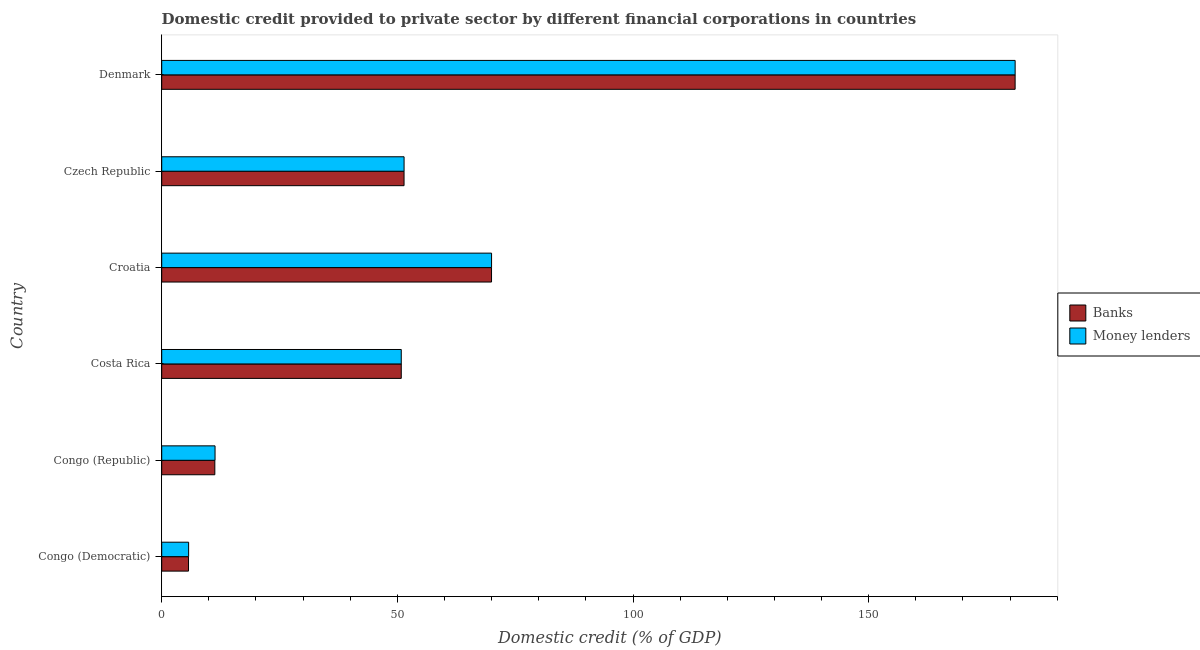How many different coloured bars are there?
Give a very brief answer. 2. How many groups of bars are there?
Make the answer very short. 6. Are the number of bars on each tick of the Y-axis equal?
Offer a very short reply. Yes. How many bars are there on the 1st tick from the top?
Offer a very short reply. 2. What is the label of the 6th group of bars from the top?
Give a very brief answer. Congo (Democratic). What is the domestic credit provided by banks in Denmark?
Your answer should be compact. 181.07. Across all countries, what is the maximum domestic credit provided by banks?
Keep it short and to the point. 181.07. Across all countries, what is the minimum domestic credit provided by money lenders?
Your answer should be compact. 5.71. In which country was the domestic credit provided by money lenders minimum?
Offer a terse response. Congo (Democratic). What is the total domestic credit provided by money lenders in the graph?
Your response must be concise. 370.34. What is the difference between the domestic credit provided by money lenders in Congo (Democratic) and that in Czech Republic?
Ensure brevity in your answer.  -45.71. What is the difference between the domestic credit provided by banks in Costa Rica and the domestic credit provided by money lenders in Congo (Democratic)?
Your response must be concise. 45.12. What is the average domestic credit provided by banks per country?
Provide a short and direct response. 61.71. What is the difference between the domestic credit provided by banks and domestic credit provided by money lenders in Denmark?
Keep it short and to the point. -0. Is the difference between the domestic credit provided by banks in Congo (Democratic) and Czech Republic greater than the difference between the domestic credit provided by money lenders in Congo (Democratic) and Czech Republic?
Your response must be concise. No. What is the difference between the highest and the second highest domestic credit provided by money lenders?
Keep it short and to the point. 111.09. What is the difference between the highest and the lowest domestic credit provided by money lenders?
Your response must be concise. 175.37. In how many countries, is the domestic credit provided by banks greater than the average domestic credit provided by banks taken over all countries?
Your answer should be compact. 2. What does the 1st bar from the top in Denmark represents?
Provide a succinct answer. Money lenders. What does the 1st bar from the bottom in Costa Rica represents?
Ensure brevity in your answer.  Banks. How many countries are there in the graph?
Offer a terse response. 6. What is the difference between two consecutive major ticks on the X-axis?
Ensure brevity in your answer.  50. Does the graph contain grids?
Offer a very short reply. No. How many legend labels are there?
Offer a terse response. 2. What is the title of the graph?
Make the answer very short. Domestic credit provided to private sector by different financial corporations in countries. Does "Revenue" appear as one of the legend labels in the graph?
Offer a very short reply. No. What is the label or title of the X-axis?
Provide a short and direct response. Domestic credit (% of GDP). What is the label or title of the Y-axis?
Provide a succinct answer. Country. What is the Domestic credit (% of GDP) in Banks in Congo (Democratic)?
Offer a terse response. 5.69. What is the Domestic credit (% of GDP) of Money lenders in Congo (Democratic)?
Provide a succinct answer. 5.71. What is the Domestic credit (% of GDP) in Banks in Congo (Republic)?
Make the answer very short. 11.27. What is the Domestic credit (% of GDP) of Money lenders in Congo (Republic)?
Provide a short and direct response. 11.32. What is the Domestic credit (% of GDP) of Banks in Costa Rica?
Offer a very short reply. 50.83. What is the Domestic credit (% of GDP) in Money lenders in Costa Rica?
Your response must be concise. 50.83. What is the Domestic credit (% of GDP) in Banks in Croatia?
Give a very brief answer. 69.98. What is the Domestic credit (% of GDP) of Money lenders in Croatia?
Ensure brevity in your answer.  69.99. What is the Domestic credit (% of GDP) in Banks in Czech Republic?
Your answer should be very brief. 51.42. What is the Domestic credit (% of GDP) in Money lenders in Czech Republic?
Keep it short and to the point. 51.42. What is the Domestic credit (% of GDP) of Banks in Denmark?
Offer a terse response. 181.07. What is the Domestic credit (% of GDP) of Money lenders in Denmark?
Make the answer very short. 181.08. Across all countries, what is the maximum Domestic credit (% of GDP) of Banks?
Your answer should be very brief. 181.07. Across all countries, what is the maximum Domestic credit (% of GDP) in Money lenders?
Keep it short and to the point. 181.08. Across all countries, what is the minimum Domestic credit (% of GDP) of Banks?
Your response must be concise. 5.69. Across all countries, what is the minimum Domestic credit (% of GDP) of Money lenders?
Provide a short and direct response. 5.71. What is the total Domestic credit (% of GDP) of Banks in the graph?
Offer a terse response. 370.26. What is the total Domestic credit (% of GDP) of Money lenders in the graph?
Offer a terse response. 370.34. What is the difference between the Domestic credit (% of GDP) in Banks in Congo (Democratic) and that in Congo (Republic)?
Ensure brevity in your answer.  -5.58. What is the difference between the Domestic credit (% of GDP) in Money lenders in Congo (Democratic) and that in Congo (Republic)?
Offer a very short reply. -5.61. What is the difference between the Domestic credit (% of GDP) in Banks in Congo (Democratic) and that in Costa Rica?
Your answer should be very brief. -45.14. What is the difference between the Domestic credit (% of GDP) of Money lenders in Congo (Democratic) and that in Costa Rica?
Your answer should be very brief. -45.12. What is the difference between the Domestic credit (% of GDP) of Banks in Congo (Democratic) and that in Croatia?
Ensure brevity in your answer.  -64.29. What is the difference between the Domestic credit (% of GDP) in Money lenders in Congo (Democratic) and that in Croatia?
Keep it short and to the point. -64.28. What is the difference between the Domestic credit (% of GDP) of Banks in Congo (Democratic) and that in Czech Republic?
Provide a succinct answer. -45.73. What is the difference between the Domestic credit (% of GDP) in Money lenders in Congo (Democratic) and that in Czech Republic?
Your response must be concise. -45.71. What is the difference between the Domestic credit (% of GDP) of Banks in Congo (Democratic) and that in Denmark?
Give a very brief answer. -175.39. What is the difference between the Domestic credit (% of GDP) in Money lenders in Congo (Democratic) and that in Denmark?
Keep it short and to the point. -175.37. What is the difference between the Domestic credit (% of GDP) in Banks in Congo (Republic) and that in Costa Rica?
Your response must be concise. -39.56. What is the difference between the Domestic credit (% of GDP) of Money lenders in Congo (Republic) and that in Costa Rica?
Offer a very short reply. -39.51. What is the difference between the Domestic credit (% of GDP) of Banks in Congo (Republic) and that in Croatia?
Offer a terse response. -58.71. What is the difference between the Domestic credit (% of GDP) in Money lenders in Congo (Republic) and that in Croatia?
Your answer should be very brief. -58.67. What is the difference between the Domestic credit (% of GDP) in Banks in Congo (Republic) and that in Czech Republic?
Your answer should be very brief. -40.15. What is the difference between the Domestic credit (% of GDP) in Money lenders in Congo (Republic) and that in Czech Republic?
Offer a terse response. -40.11. What is the difference between the Domestic credit (% of GDP) in Banks in Congo (Republic) and that in Denmark?
Make the answer very short. -169.8. What is the difference between the Domestic credit (% of GDP) of Money lenders in Congo (Republic) and that in Denmark?
Your answer should be compact. -169.76. What is the difference between the Domestic credit (% of GDP) of Banks in Costa Rica and that in Croatia?
Make the answer very short. -19.15. What is the difference between the Domestic credit (% of GDP) of Money lenders in Costa Rica and that in Croatia?
Provide a short and direct response. -19.16. What is the difference between the Domestic credit (% of GDP) in Banks in Costa Rica and that in Czech Republic?
Your answer should be compact. -0.59. What is the difference between the Domestic credit (% of GDP) of Money lenders in Costa Rica and that in Czech Republic?
Your answer should be very brief. -0.59. What is the difference between the Domestic credit (% of GDP) in Banks in Costa Rica and that in Denmark?
Keep it short and to the point. -130.25. What is the difference between the Domestic credit (% of GDP) in Money lenders in Costa Rica and that in Denmark?
Your answer should be very brief. -130.25. What is the difference between the Domestic credit (% of GDP) of Banks in Croatia and that in Czech Republic?
Your answer should be compact. 18.56. What is the difference between the Domestic credit (% of GDP) of Money lenders in Croatia and that in Czech Republic?
Your response must be concise. 18.56. What is the difference between the Domestic credit (% of GDP) of Banks in Croatia and that in Denmark?
Your answer should be very brief. -111.09. What is the difference between the Domestic credit (% of GDP) of Money lenders in Croatia and that in Denmark?
Your response must be concise. -111.09. What is the difference between the Domestic credit (% of GDP) of Banks in Czech Republic and that in Denmark?
Give a very brief answer. -129.66. What is the difference between the Domestic credit (% of GDP) in Money lenders in Czech Republic and that in Denmark?
Offer a terse response. -129.65. What is the difference between the Domestic credit (% of GDP) in Banks in Congo (Democratic) and the Domestic credit (% of GDP) in Money lenders in Congo (Republic)?
Offer a terse response. -5.63. What is the difference between the Domestic credit (% of GDP) of Banks in Congo (Democratic) and the Domestic credit (% of GDP) of Money lenders in Costa Rica?
Keep it short and to the point. -45.14. What is the difference between the Domestic credit (% of GDP) in Banks in Congo (Democratic) and the Domestic credit (% of GDP) in Money lenders in Croatia?
Provide a succinct answer. -64.3. What is the difference between the Domestic credit (% of GDP) in Banks in Congo (Democratic) and the Domestic credit (% of GDP) in Money lenders in Czech Republic?
Offer a very short reply. -45.74. What is the difference between the Domestic credit (% of GDP) in Banks in Congo (Democratic) and the Domestic credit (% of GDP) in Money lenders in Denmark?
Provide a succinct answer. -175.39. What is the difference between the Domestic credit (% of GDP) of Banks in Congo (Republic) and the Domestic credit (% of GDP) of Money lenders in Costa Rica?
Ensure brevity in your answer.  -39.56. What is the difference between the Domestic credit (% of GDP) of Banks in Congo (Republic) and the Domestic credit (% of GDP) of Money lenders in Croatia?
Ensure brevity in your answer.  -58.72. What is the difference between the Domestic credit (% of GDP) of Banks in Congo (Republic) and the Domestic credit (% of GDP) of Money lenders in Czech Republic?
Keep it short and to the point. -40.15. What is the difference between the Domestic credit (% of GDP) in Banks in Congo (Republic) and the Domestic credit (% of GDP) in Money lenders in Denmark?
Your response must be concise. -169.81. What is the difference between the Domestic credit (% of GDP) in Banks in Costa Rica and the Domestic credit (% of GDP) in Money lenders in Croatia?
Provide a succinct answer. -19.16. What is the difference between the Domestic credit (% of GDP) of Banks in Costa Rica and the Domestic credit (% of GDP) of Money lenders in Czech Republic?
Offer a very short reply. -0.59. What is the difference between the Domestic credit (% of GDP) in Banks in Costa Rica and the Domestic credit (% of GDP) in Money lenders in Denmark?
Your response must be concise. -130.25. What is the difference between the Domestic credit (% of GDP) of Banks in Croatia and the Domestic credit (% of GDP) of Money lenders in Czech Republic?
Give a very brief answer. 18.56. What is the difference between the Domestic credit (% of GDP) of Banks in Croatia and the Domestic credit (% of GDP) of Money lenders in Denmark?
Provide a short and direct response. -111.1. What is the difference between the Domestic credit (% of GDP) of Banks in Czech Republic and the Domestic credit (% of GDP) of Money lenders in Denmark?
Make the answer very short. -129.66. What is the average Domestic credit (% of GDP) in Banks per country?
Offer a terse response. 61.71. What is the average Domestic credit (% of GDP) of Money lenders per country?
Keep it short and to the point. 61.72. What is the difference between the Domestic credit (% of GDP) in Banks and Domestic credit (% of GDP) in Money lenders in Congo (Democratic)?
Your answer should be compact. -0.02. What is the difference between the Domestic credit (% of GDP) in Banks and Domestic credit (% of GDP) in Money lenders in Congo (Republic)?
Offer a terse response. -0.05. What is the difference between the Domestic credit (% of GDP) in Banks and Domestic credit (% of GDP) in Money lenders in Croatia?
Your answer should be very brief. -0.01. What is the difference between the Domestic credit (% of GDP) in Banks and Domestic credit (% of GDP) in Money lenders in Czech Republic?
Your answer should be very brief. -0. What is the difference between the Domestic credit (% of GDP) of Banks and Domestic credit (% of GDP) of Money lenders in Denmark?
Your answer should be compact. -0. What is the ratio of the Domestic credit (% of GDP) of Banks in Congo (Democratic) to that in Congo (Republic)?
Give a very brief answer. 0.5. What is the ratio of the Domestic credit (% of GDP) of Money lenders in Congo (Democratic) to that in Congo (Republic)?
Make the answer very short. 0.5. What is the ratio of the Domestic credit (% of GDP) of Banks in Congo (Democratic) to that in Costa Rica?
Keep it short and to the point. 0.11. What is the ratio of the Domestic credit (% of GDP) in Money lenders in Congo (Democratic) to that in Costa Rica?
Keep it short and to the point. 0.11. What is the ratio of the Domestic credit (% of GDP) in Banks in Congo (Democratic) to that in Croatia?
Offer a very short reply. 0.08. What is the ratio of the Domestic credit (% of GDP) of Money lenders in Congo (Democratic) to that in Croatia?
Make the answer very short. 0.08. What is the ratio of the Domestic credit (% of GDP) of Banks in Congo (Democratic) to that in Czech Republic?
Provide a succinct answer. 0.11. What is the ratio of the Domestic credit (% of GDP) of Banks in Congo (Democratic) to that in Denmark?
Ensure brevity in your answer.  0.03. What is the ratio of the Domestic credit (% of GDP) of Money lenders in Congo (Democratic) to that in Denmark?
Give a very brief answer. 0.03. What is the ratio of the Domestic credit (% of GDP) in Banks in Congo (Republic) to that in Costa Rica?
Make the answer very short. 0.22. What is the ratio of the Domestic credit (% of GDP) in Money lenders in Congo (Republic) to that in Costa Rica?
Your answer should be very brief. 0.22. What is the ratio of the Domestic credit (% of GDP) in Banks in Congo (Republic) to that in Croatia?
Provide a succinct answer. 0.16. What is the ratio of the Domestic credit (% of GDP) of Money lenders in Congo (Republic) to that in Croatia?
Your response must be concise. 0.16. What is the ratio of the Domestic credit (% of GDP) of Banks in Congo (Republic) to that in Czech Republic?
Provide a succinct answer. 0.22. What is the ratio of the Domestic credit (% of GDP) of Money lenders in Congo (Republic) to that in Czech Republic?
Offer a very short reply. 0.22. What is the ratio of the Domestic credit (% of GDP) in Banks in Congo (Republic) to that in Denmark?
Offer a very short reply. 0.06. What is the ratio of the Domestic credit (% of GDP) in Money lenders in Congo (Republic) to that in Denmark?
Make the answer very short. 0.06. What is the ratio of the Domestic credit (% of GDP) in Banks in Costa Rica to that in Croatia?
Offer a very short reply. 0.73. What is the ratio of the Domestic credit (% of GDP) in Money lenders in Costa Rica to that in Croatia?
Keep it short and to the point. 0.73. What is the ratio of the Domestic credit (% of GDP) in Money lenders in Costa Rica to that in Czech Republic?
Your answer should be compact. 0.99. What is the ratio of the Domestic credit (% of GDP) in Banks in Costa Rica to that in Denmark?
Keep it short and to the point. 0.28. What is the ratio of the Domestic credit (% of GDP) in Money lenders in Costa Rica to that in Denmark?
Keep it short and to the point. 0.28. What is the ratio of the Domestic credit (% of GDP) in Banks in Croatia to that in Czech Republic?
Your response must be concise. 1.36. What is the ratio of the Domestic credit (% of GDP) of Money lenders in Croatia to that in Czech Republic?
Ensure brevity in your answer.  1.36. What is the ratio of the Domestic credit (% of GDP) in Banks in Croatia to that in Denmark?
Ensure brevity in your answer.  0.39. What is the ratio of the Domestic credit (% of GDP) of Money lenders in Croatia to that in Denmark?
Offer a very short reply. 0.39. What is the ratio of the Domestic credit (% of GDP) of Banks in Czech Republic to that in Denmark?
Offer a terse response. 0.28. What is the ratio of the Domestic credit (% of GDP) of Money lenders in Czech Republic to that in Denmark?
Provide a short and direct response. 0.28. What is the difference between the highest and the second highest Domestic credit (% of GDP) in Banks?
Give a very brief answer. 111.09. What is the difference between the highest and the second highest Domestic credit (% of GDP) of Money lenders?
Provide a short and direct response. 111.09. What is the difference between the highest and the lowest Domestic credit (% of GDP) of Banks?
Your answer should be compact. 175.39. What is the difference between the highest and the lowest Domestic credit (% of GDP) in Money lenders?
Provide a succinct answer. 175.37. 